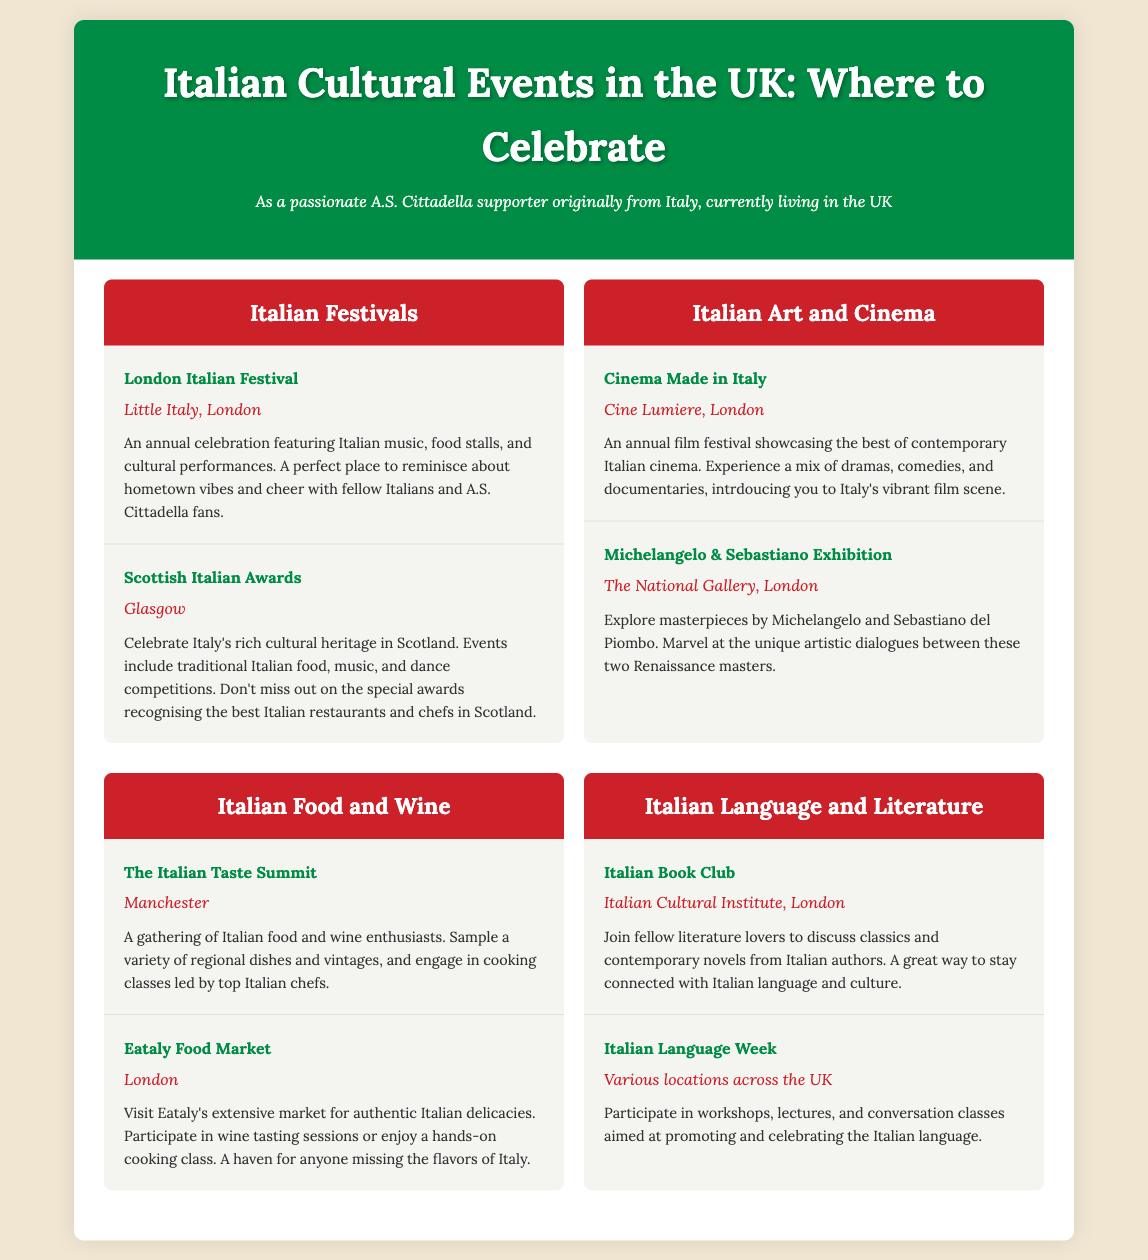What is the name of the festival celebrated in Little Italy, London? The festival is specifically mentioned as the London Italian Festival in the document.
Answer: London Italian Festival Where do the Scottish Italian Awards take place? The specific location for the Scottish Italian Awards is provided as Glasgow in the document.
Answer: Glasgow What type of event is Cinema Made in Italy? The event is described as an annual film festival showcasing contemporary Italian cinema.
Answer: Film festival Which art exhibition features masterpieces by Michelangelo? The document states the specific exhibition is the Michelangelo & Sebastiano Exhibition.
Answer: Michelangelo & Sebastiano Exhibition What is the focus of the Italian Taste Summit? The document indicates that the event is focused on Italian food and wine enthusiasts.
Answer: Food and wine How often is Italian Language Week held? The document implies that the event is held annually, as it is described as week-long celebrations.
Answer: Annually What kind of activities are included in the Italian Language Week? The activities mentioned include workshops, lectures, and conversation classes aimed at promoting the Italian language.
Answer: Workshops, lectures, conversation classes Which city hosts the Eataly Food Market? The document clearly indicates that the Eataly Food Market is located in London.
Answer: London What genre of literature does the Italian Book Club focus on? The focus of the Italian Book Club is on classics and contemporary novels from Italian authors.
Answer: Classics and contemporary novels What is a common featured aspect of the described Italian festivals? The document mentions that the festivals include Italian music, food stalls, and cultural performances.
Answer: Music, food stalls, cultural performances 